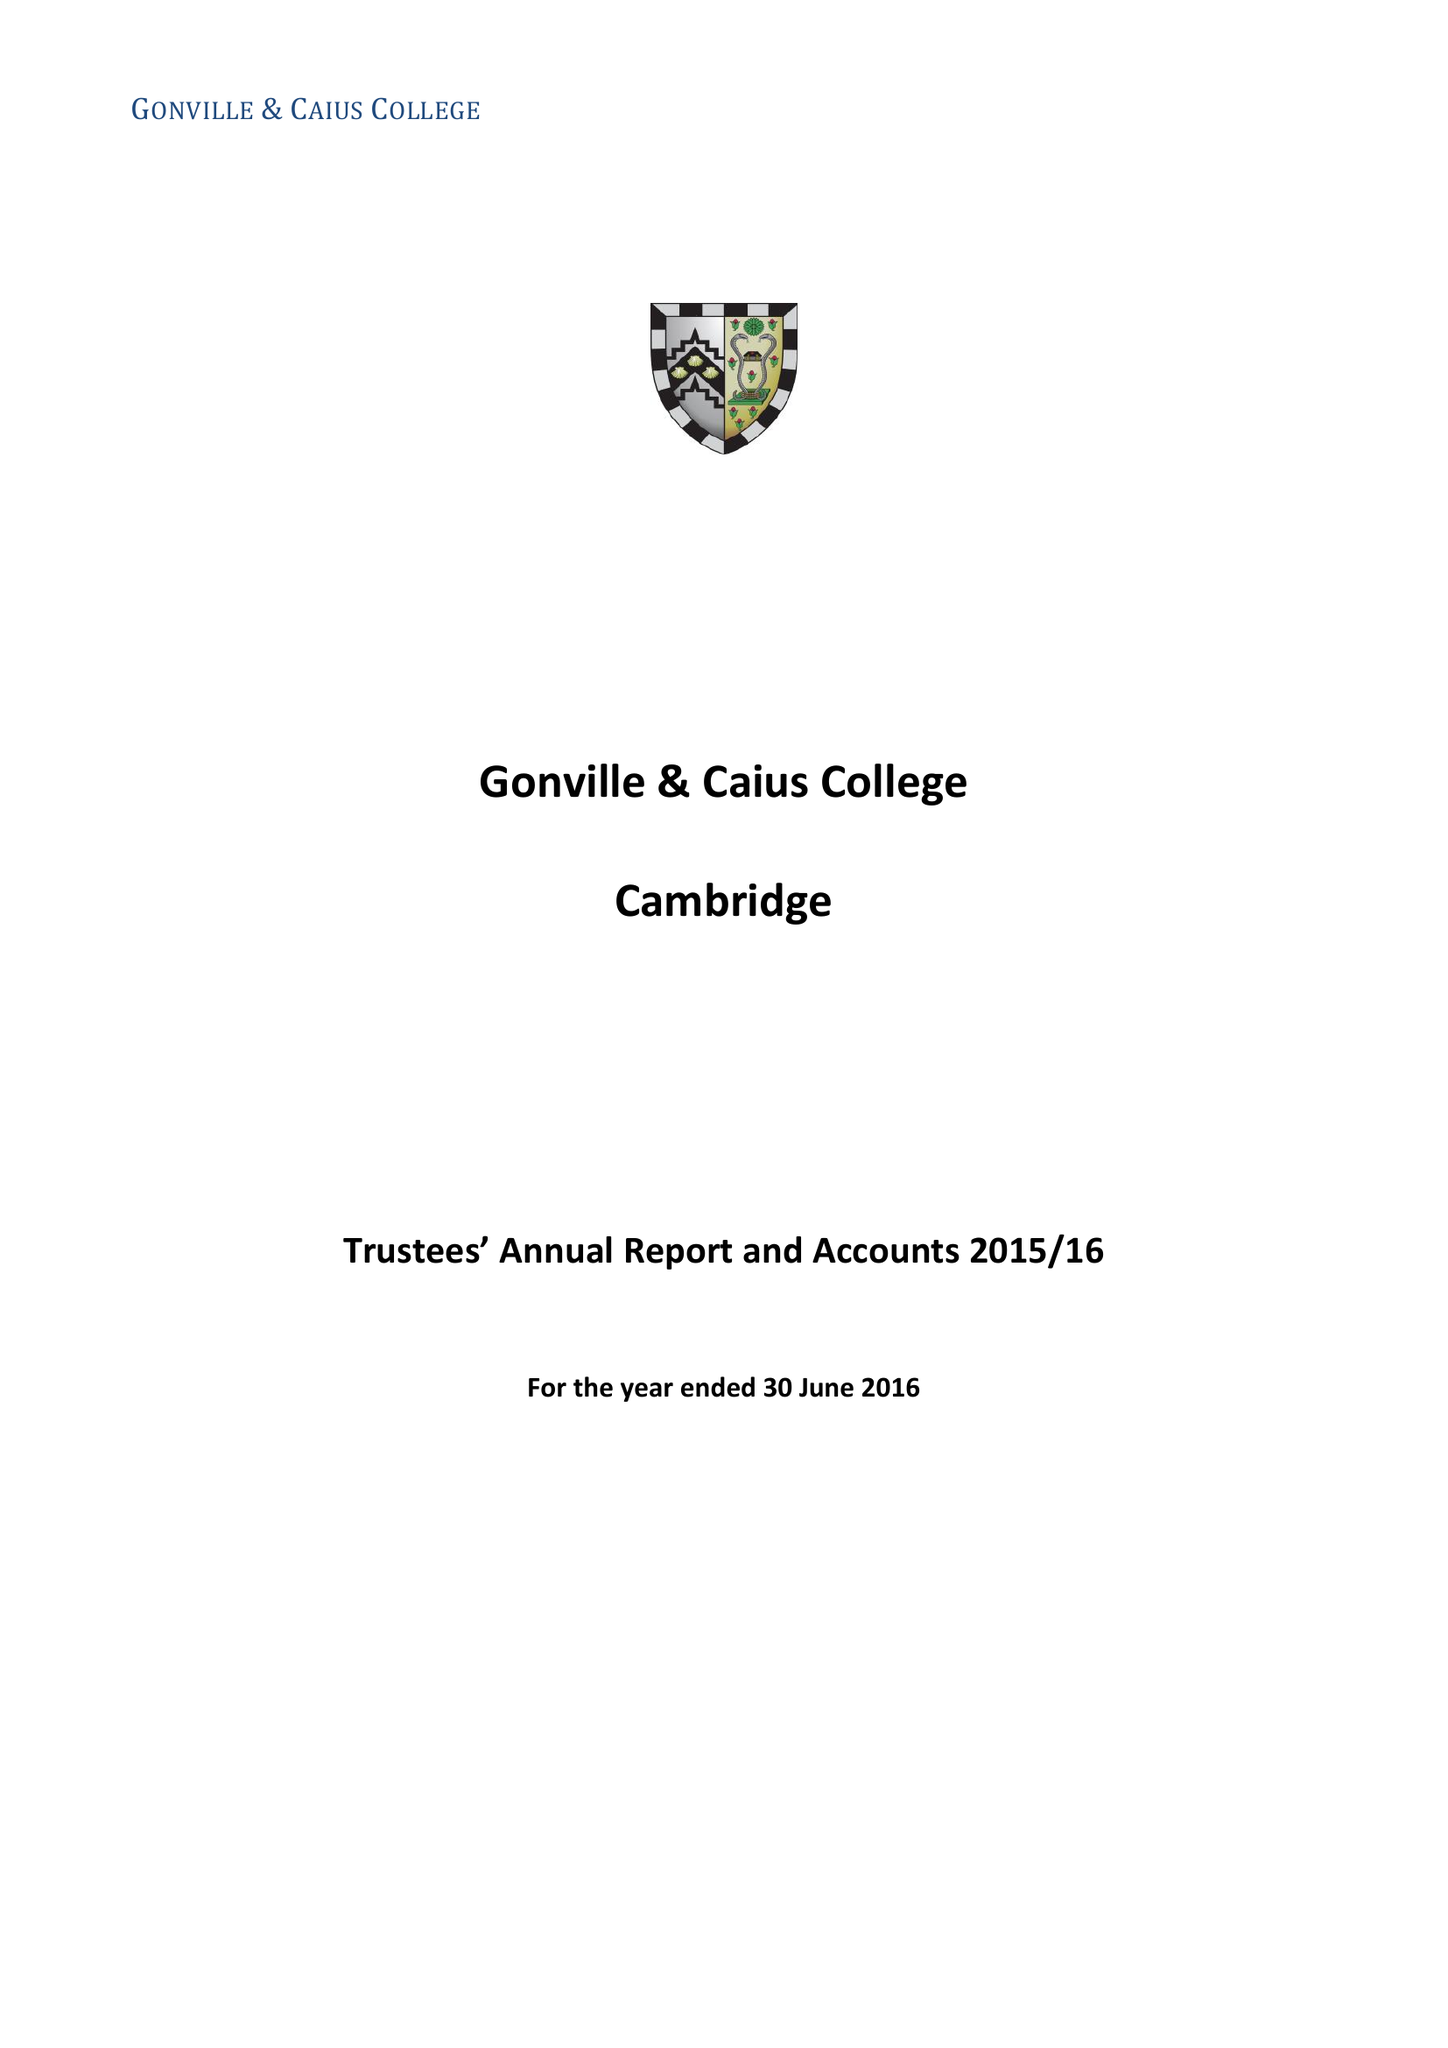What is the value for the charity_number?
Answer the question using a single word or phrase. 1137536 